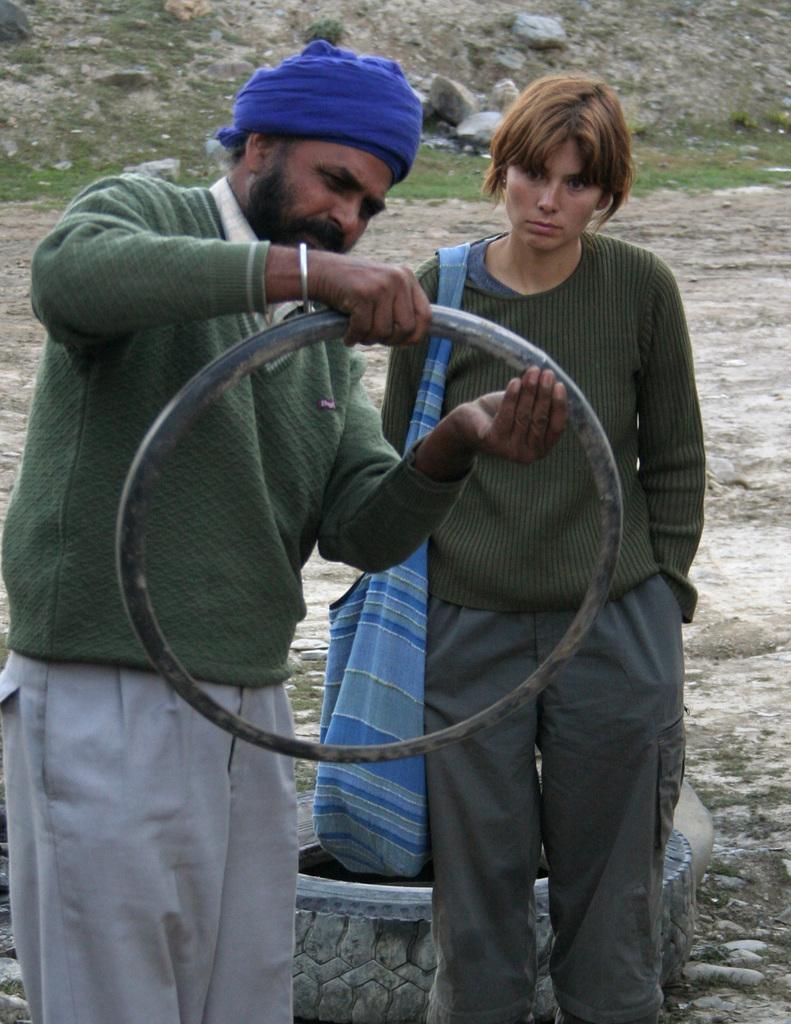Can you describe this image briefly? In this picture I can see at the bottom there is a tyre, on the left side there is a man, he is standing and holding an iron frame, beside him there is a woman. She is wearing a bag, in the background there are stones. 